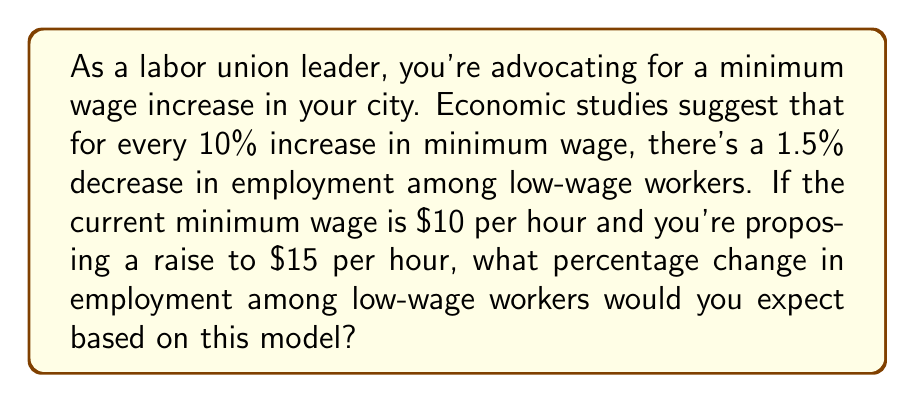What is the answer to this math problem? To solve this problem, we need to follow these steps:

1. Calculate the percentage increase in minimum wage:
   Let $x$ be the percentage increase in minimum wage.
   $$x = \frac{\text{New wage} - \text{Old wage}}{\text{Old wage}} \times 100\%$$
   $$x = \frac{15 - 10}{10} \times 100\% = 50\%$$

2. Determine the relationship between wage increase and employment decrease:
   For every 10% increase in minimum wage, there's a 1.5% decrease in employment.
   We can express this as a ratio:
   $$\frac{\text{Employment decrease}}{\text{Wage increase}} = \frac{1.5\%}{10\%} = 0.15$$

3. Calculate the expected employment decrease:
   Let $y$ be the percentage decrease in employment.
   $$y = 0.15 \times 50\% = 7.5\%$$

Therefore, based on this economic model, we would expect a 7.5% decrease in employment among low-wage workers.
Answer: 7.5% 